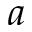Convert formula to latex. <formula><loc_0><loc_0><loc_500><loc_500>a</formula> 